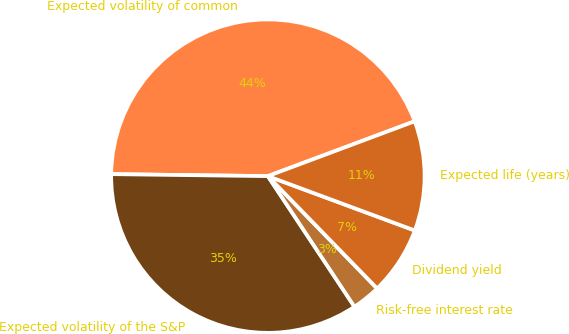<chart> <loc_0><loc_0><loc_500><loc_500><pie_chart><fcel>Expected volatility of common<fcel>Expected volatility of the S&P<fcel>Risk-free interest rate<fcel>Dividend yield<fcel>Expected life (years)<nl><fcel>44.11%<fcel>34.52%<fcel>2.96%<fcel>7.08%<fcel>11.33%<nl></chart> 